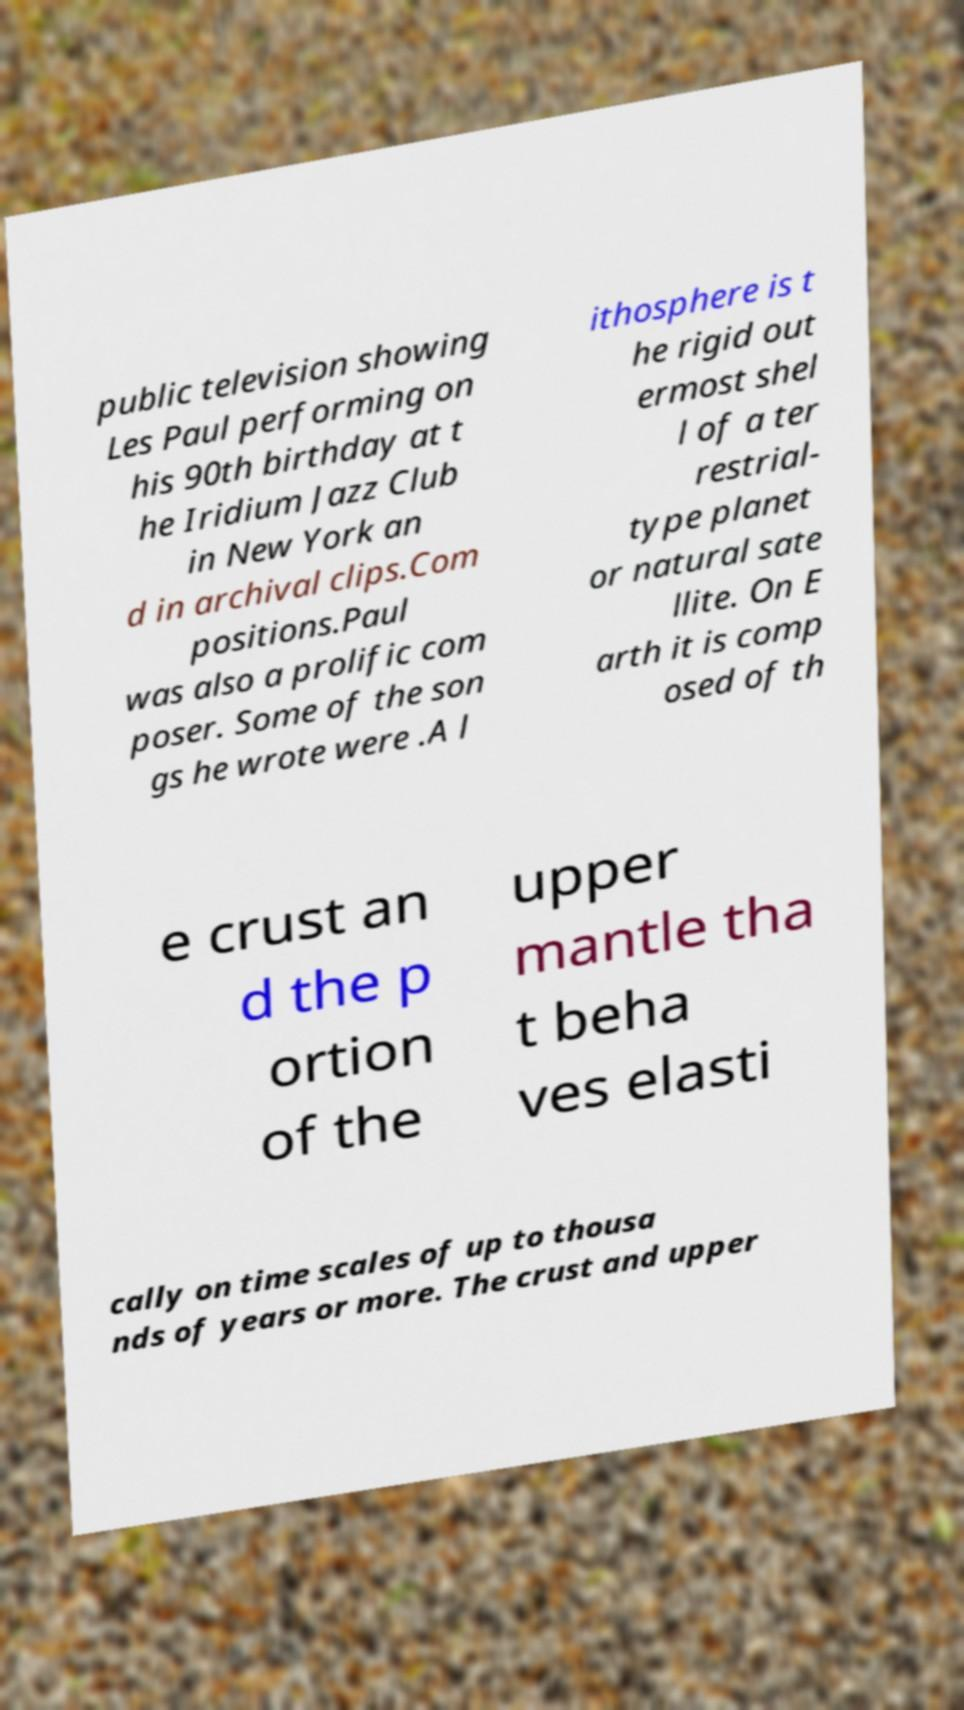Can you accurately transcribe the text from the provided image for me? public television showing Les Paul performing on his 90th birthday at t he Iridium Jazz Club in New York an d in archival clips.Com positions.Paul was also a prolific com poser. Some of the son gs he wrote were .A l ithosphere is t he rigid out ermost shel l of a ter restrial- type planet or natural sate llite. On E arth it is comp osed of th e crust an d the p ortion of the upper mantle tha t beha ves elasti cally on time scales of up to thousa nds of years or more. The crust and upper 